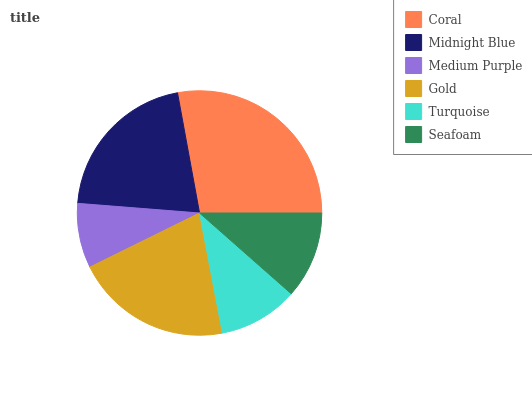Is Medium Purple the minimum?
Answer yes or no. Yes. Is Coral the maximum?
Answer yes or no. Yes. Is Midnight Blue the minimum?
Answer yes or no. No. Is Midnight Blue the maximum?
Answer yes or no. No. Is Coral greater than Midnight Blue?
Answer yes or no. Yes. Is Midnight Blue less than Coral?
Answer yes or no. Yes. Is Midnight Blue greater than Coral?
Answer yes or no. No. Is Coral less than Midnight Blue?
Answer yes or no. No. Is Gold the high median?
Answer yes or no. Yes. Is Seafoam the low median?
Answer yes or no. Yes. Is Seafoam the high median?
Answer yes or no. No. Is Medium Purple the low median?
Answer yes or no. No. 